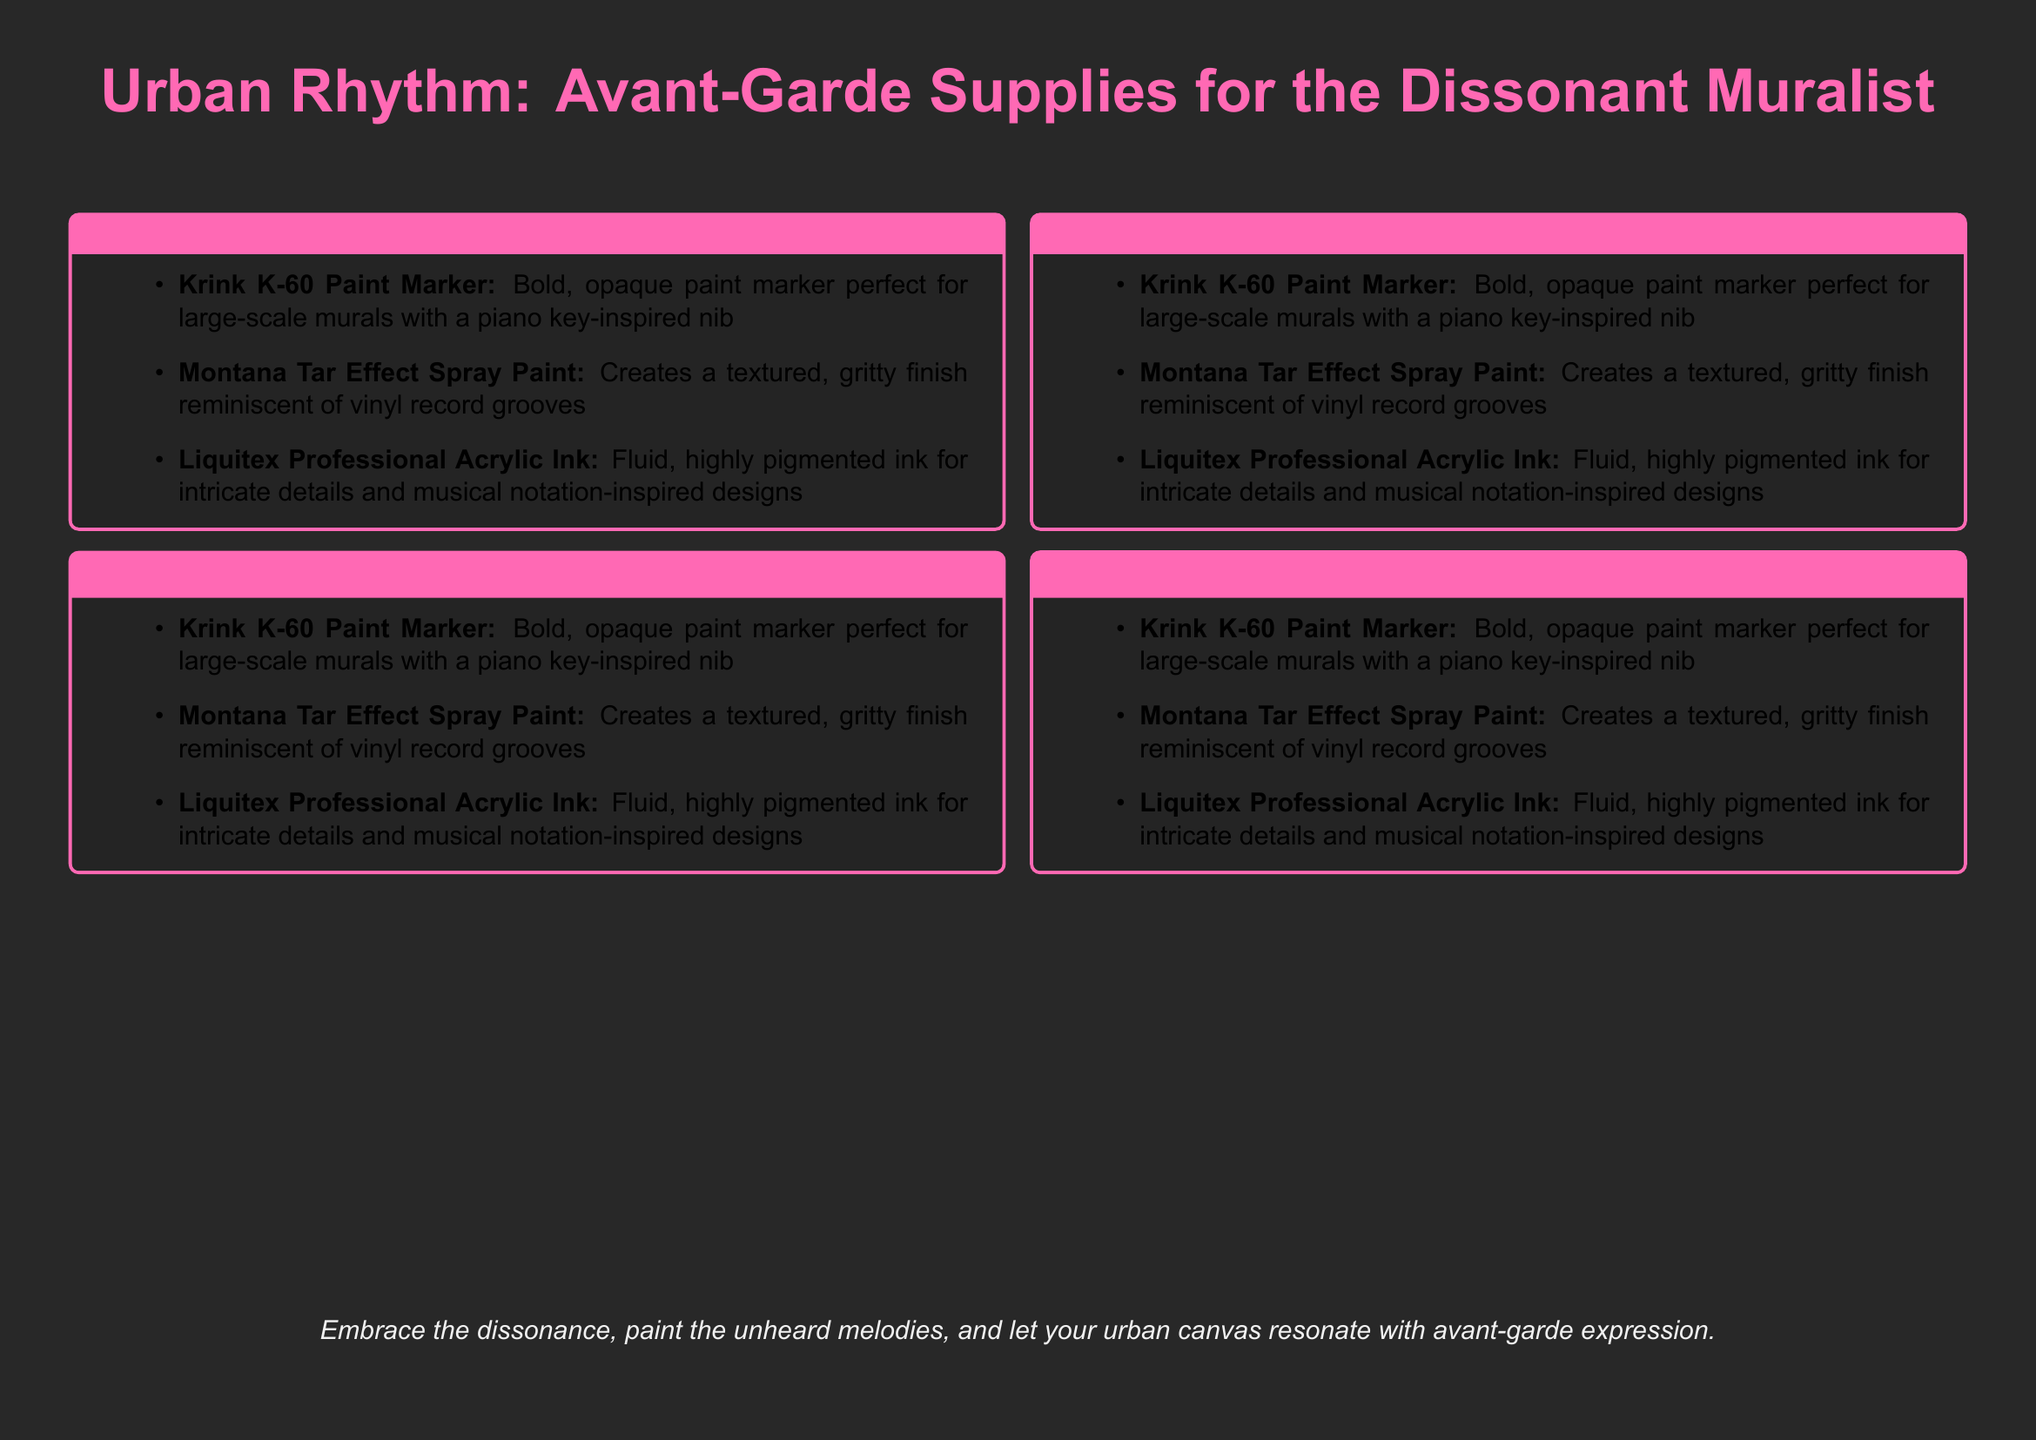What are the unconventional paint media listed? The document lists three unconventional paint media in the section titled "Unconventional Paint Media".
Answer: Krink K-60 Paint Marker, Montana Tar Effect Spray Paint, Liquitex Professional Acrylic Ink What is the primary color of the catalog's background? The document specifies the background color using RGB values, which can be identified in the styling.
Answer: Dark gray What is the title of the catalog? The document clearly presents the title at the beginning.
Answer: Urban Rhythm: Avant-Garde Supplies for the Dissonant Muralist How many sections does the document have? The document outlines four sections, which can be identified individually.
Answer: Four What type of marker is the Krink K-60? The Krink K-60 is mentioned as a type of bold paint marker.
Answer: Paint marker What texture does the Montana Tar Effect Spray Paint create? The document specifically describes the finish created by this spray paint.
Answer: Textured, gritty What is the intention of the closing statement? The final statement encourages a specific action or attitude towards urban mural painting.
Answer: Embrace dissonance Which section includes the Liquitex Professional Acrylic Ink? The product is listed in the section related to paint media.
Answer: Unconventional Paint Media 